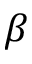<formula> <loc_0><loc_0><loc_500><loc_500>\beta</formula> 